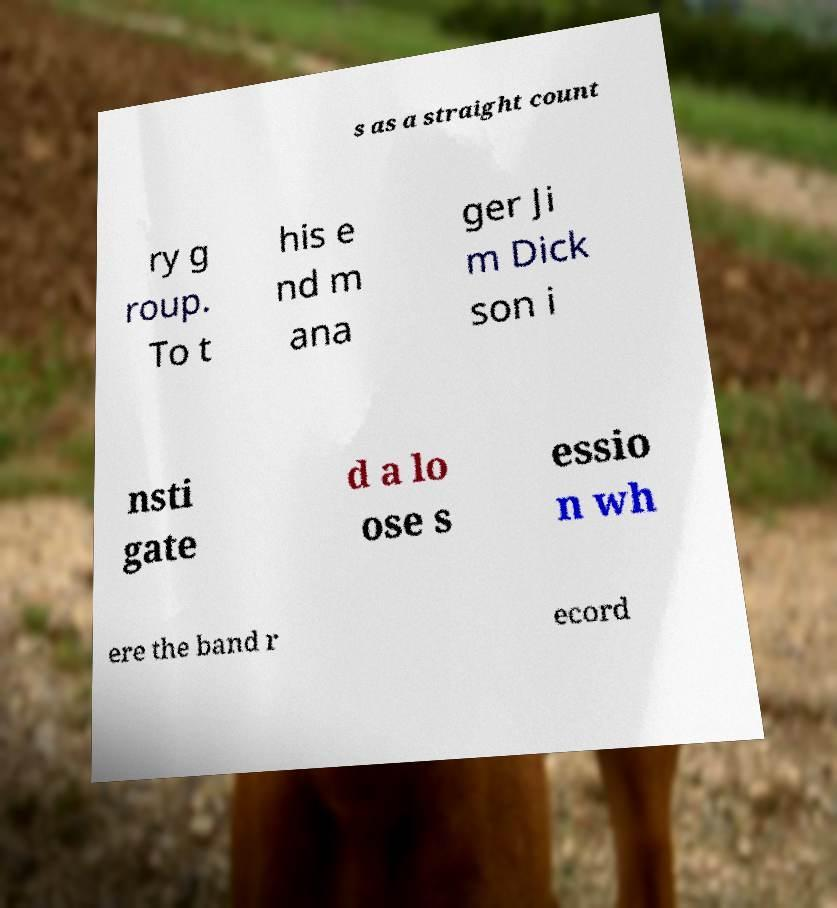Please read and relay the text visible in this image. What does it say? s as a straight count ry g roup. To t his e nd m ana ger Ji m Dick son i nsti gate d a lo ose s essio n wh ere the band r ecord 